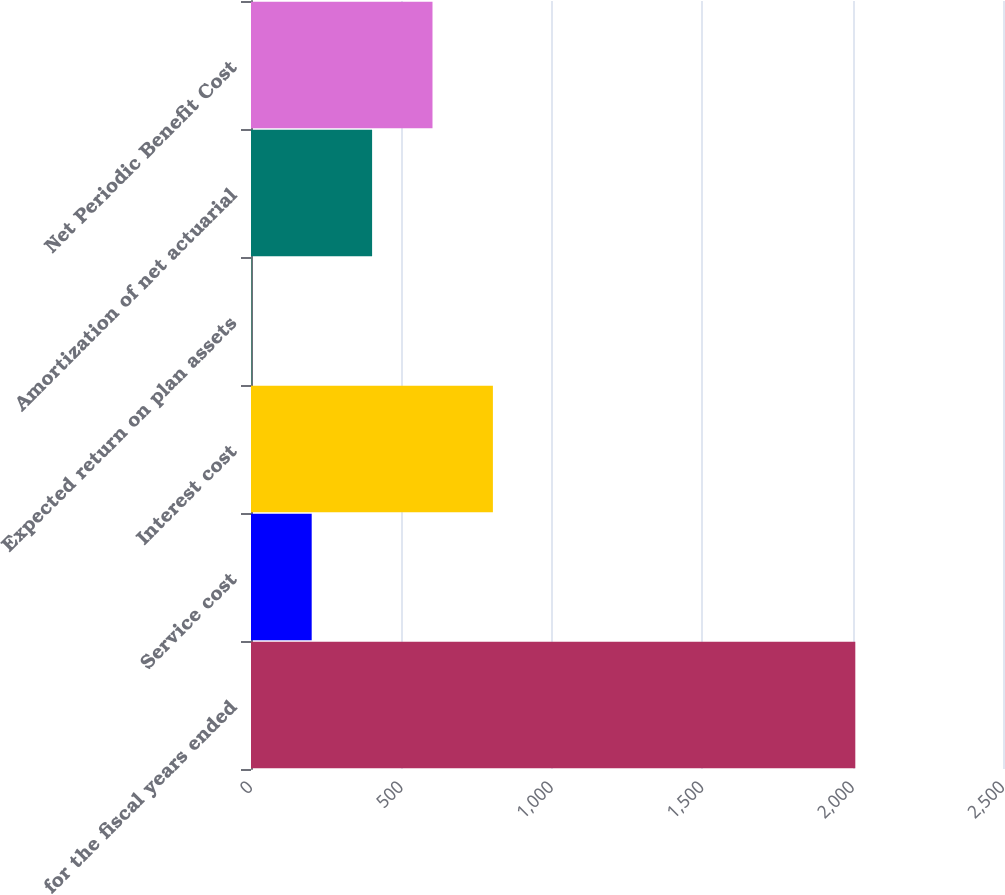<chart> <loc_0><loc_0><loc_500><loc_500><bar_chart><fcel>for the fiscal years ended<fcel>Service cost<fcel>Interest cost<fcel>Expected return on plan assets<fcel>Amortization of net actuarial<fcel>Net Periodic Benefit Cost<nl><fcel>2009<fcel>201.79<fcel>804.19<fcel>0.99<fcel>402.59<fcel>603.39<nl></chart> 